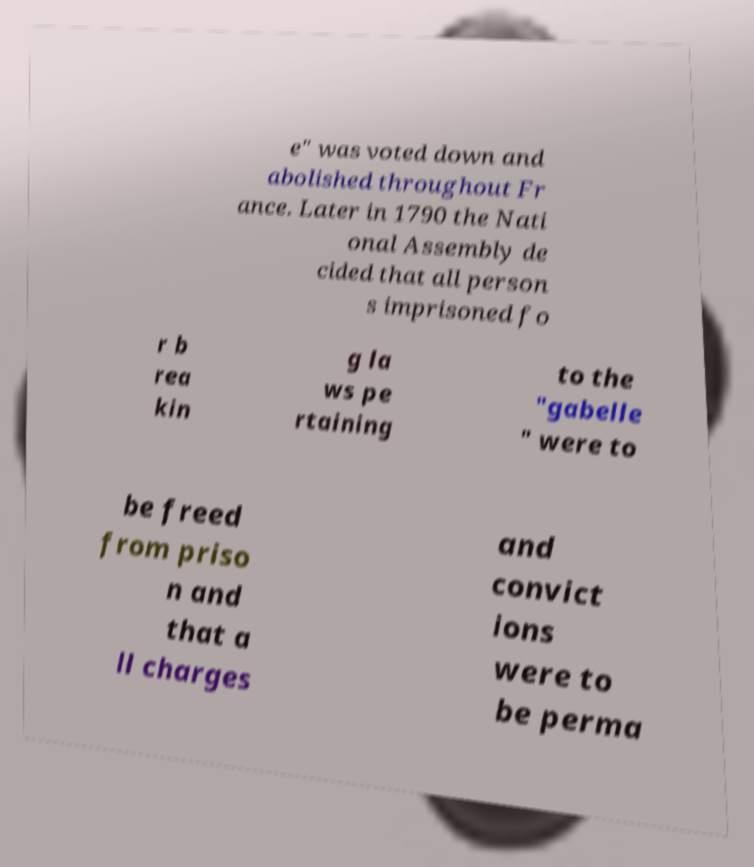Can you read and provide the text displayed in the image?This photo seems to have some interesting text. Can you extract and type it out for me? e" was voted down and abolished throughout Fr ance. Later in 1790 the Nati onal Assembly de cided that all person s imprisoned fo r b rea kin g la ws pe rtaining to the "gabelle " were to be freed from priso n and that a ll charges and convict ions were to be perma 